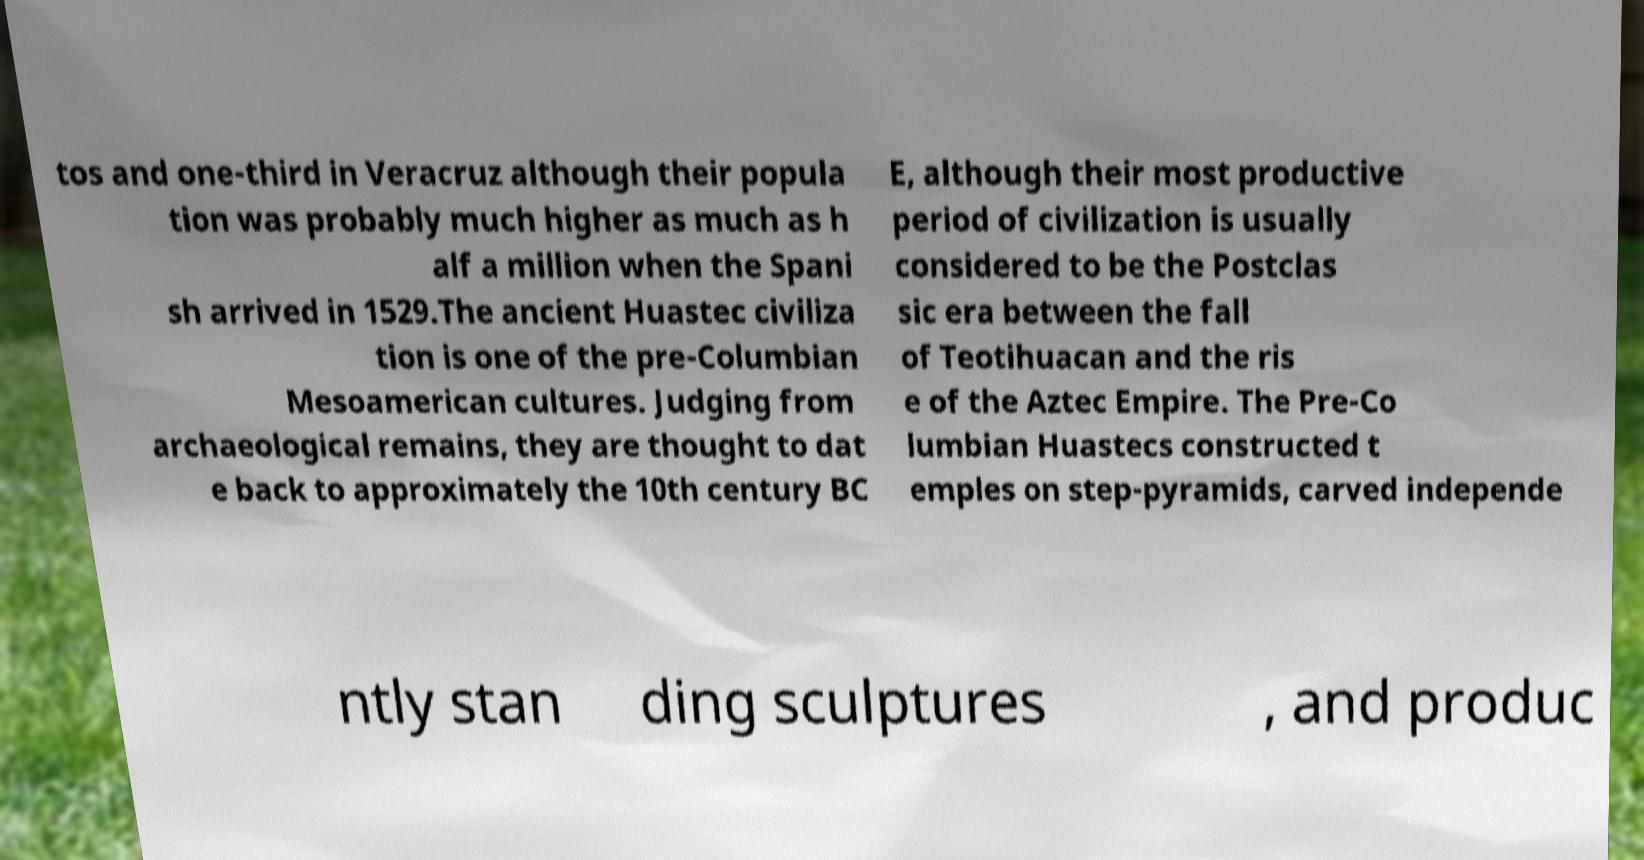There's text embedded in this image that I need extracted. Can you transcribe it verbatim? tos and one-third in Veracruz although their popula tion was probably much higher as much as h alf a million when the Spani sh arrived in 1529.The ancient Huastec civiliza tion is one of the pre-Columbian Mesoamerican cultures. Judging from archaeological remains, they are thought to dat e back to approximately the 10th century BC E, although their most productive period of civilization is usually considered to be the Postclas sic era between the fall of Teotihuacan and the ris e of the Aztec Empire. The Pre-Co lumbian Huastecs constructed t emples on step-pyramids, carved independe ntly stan ding sculptures , and produc 